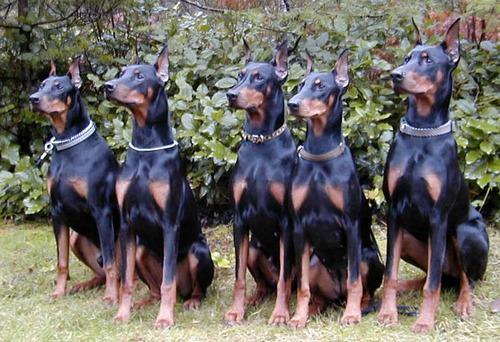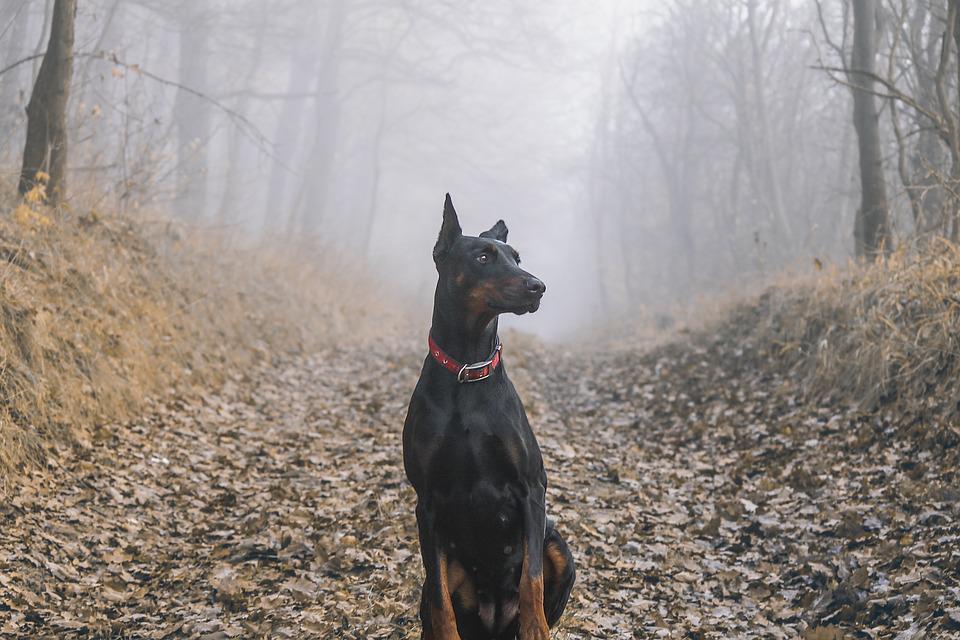The first image is the image on the left, the second image is the image on the right. Assess this claim about the two images: "There are more dogs in the left image than in the right image.". Correct or not? Answer yes or no. Yes. The first image is the image on the left, the second image is the image on the right. Assess this claim about the two images: "An image shows a person at the center of an outdoor scene, surrounded by a group of pointy-eared adult dobermans wearing collars.". Correct or not? Answer yes or no. No. 